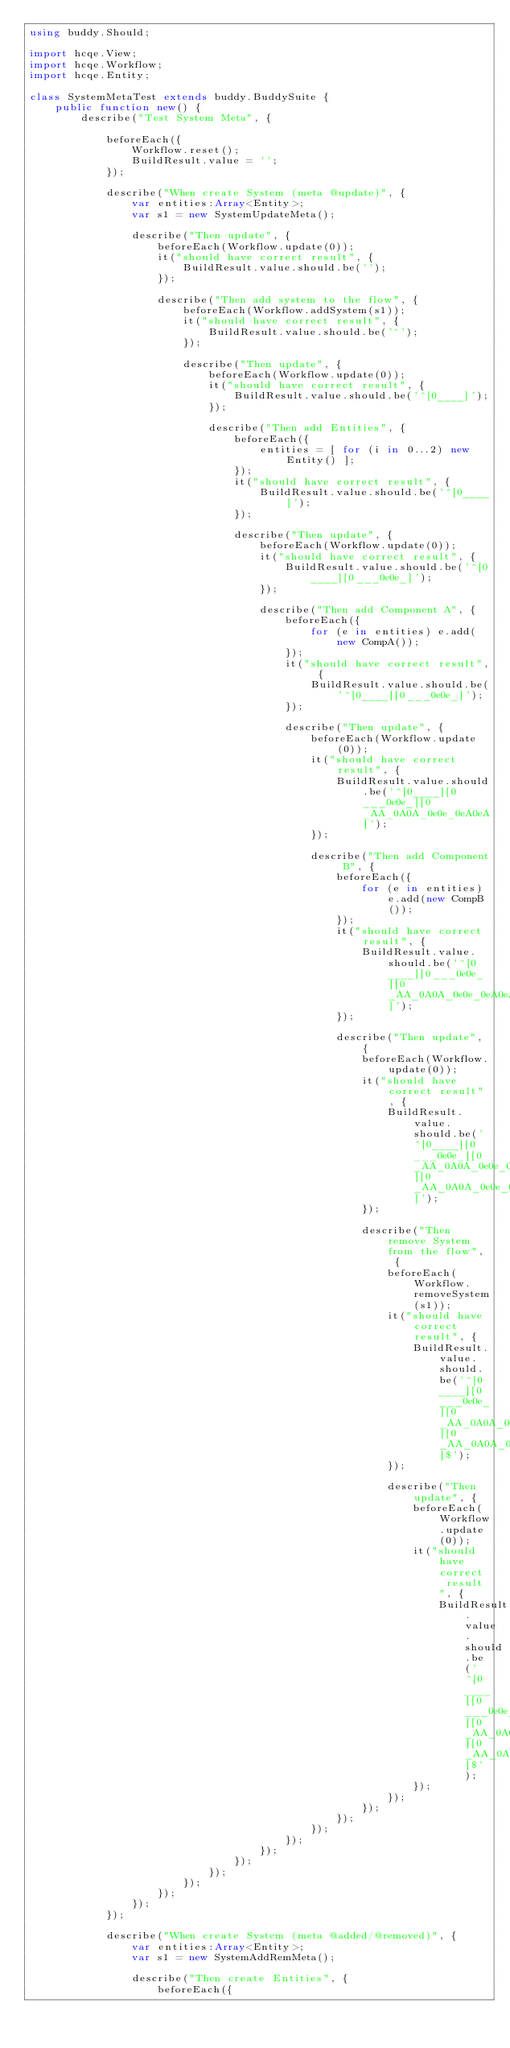Convert code to text. <code><loc_0><loc_0><loc_500><loc_500><_Haxe_>using buddy.Should;

import hcqe.View;
import hcqe.Workflow;
import hcqe.Entity;

class SystemMetaTest extends buddy.BuddySuite {
    public function new() {
        describe("Test System Meta", {

            beforeEach({
                Workflow.reset();
                BuildResult.value = '';
            });

            describe("When create System (meta @update)", {
                var entities:Array<Entity>;
                var s1 = new SystemUpdateMeta();

                describe("Then update", {
                    beforeEach(Workflow.update(0));
                    it("should have correct result", {
                        BuildResult.value.should.be('');
                    });

                    describe("Then add system to the flow", {
                        beforeEach(Workflow.addSystem(s1));
                        it("should have correct result", {
                            BuildResult.value.should.be('^');
                        });

                        describe("Then update", {
                            beforeEach(Workflow.update(0));
                            it("should have correct result", {
                                BuildResult.value.should.be('^[0____]');
                            });

                            describe("Then add Entities", {
                                beforeEach({
                                    entities = [ for (i in 0...2) new Entity() ];
                                });
                                it("should have correct result", {
                                    BuildResult.value.should.be('^[0____]');
                                });
            
                                describe("Then update", {
                                    beforeEach(Workflow.update(0));
                                    it("should have correct result", {
                                        BuildResult.value.should.be('^[0____][0___0e0e_]');
                                    });

                                    describe("Then add Component A", {
                                        beforeEach({
                                            for (e in entities) e.add(new CompA());
                                        });
                                        it("should have correct result", {
                                            BuildResult.value.should.be('^[0____][0___0e0e_]');
                                        });

                                        describe("Then update", {
                                            beforeEach(Workflow.update(0));
                                            it("should have correct result", {
                                                BuildResult.value.should.be('^[0____][0___0e0e_][0_AA_0A0A_0e0e_0eA0eA]');
                                            });

                                            describe("Then add Component B", {
                                                beforeEach({
                                                    for (e in entities) e.add(new CompB());
                                                });
                                                it("should have correct result", {
                                                    BuildResult.value.should.be('^[0____][0___0e0e_][0_AA_0A0A_0e0e_0eA0eA]');
                                                });
        
                                                describe("Then update", {
                                                    beforeEach(Workflow.update(0));
                                                    it("should have correct result", {
                                                        BuildResult.value.should.be('^[0____][0___0e0e_][0_AA_0A0A_0e0e_0eA0eA][0_AA_0A0A_0e0e_0eA0eA0eB0eB0eAB0eAB]');
                                                    });

                                                    describe("Then remove System from the flow", {
                                                        beforeEach(Workflow.removeSystem(s1));
                                                        it("should have correct result", {
                                                            BuildResult.value.should.be('^[0____][0___0e0e_][0_AA_0A0A_0e0e_0eA0eA][0_AA_0A0A_0e0e_0eA0eA0eB0eB0eAB0eAB]$');
                                                        });
                            
                                                        describe("Then update", {
                                                            beforeEach(Workflow.update(0));
                                                            it("should have correct result", {
                                                                BuildResult.value.should.be('^[0____][0___0e0e_][0_AA_0A0A_0e0e_0eA0eA][0_AA_0A0A_0e0e_0eA0eA0eB0eB0eAB0eAB]$');
                                                            });
                                                        });
                                                    });
                                                });
                                            });
                                        });
                                    });
                                });
                            });
                        });
                    });
                });
            });

            describe("When create System (meta @added/@removed)", {
                var entities:Array<Entity>;
                var s1 = new SystemAddRemMeta();

                describe("Then create Entities", {
                    beforeEach({</code> 